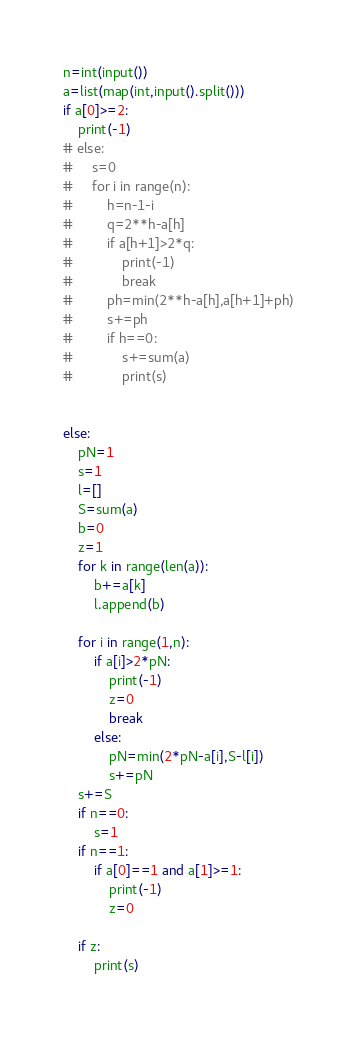Convert code to text. <code><loc_0><loc_0><loc_500><loc_500><_Python_>n=int(input())
a=list(map(int,input().split()))
if a[0]>=2:
    print(-1)
# else:
#     s=0
#     for i in range(n):
#         h=n-1-i
#         q=2**h-a[h]
#         if a[h+1]>2*q:
#             print(-1)
#             break
#         ph=min(2**h-a[h],a[h+1]+ph)
#         s+=ph
#         if h==0:
#             s+=sum(a)
#             print(s)


else:
    pN=1
    s=1
    l=[]
    S=sum(a)
    b=0
    z=1
    for k in range(len(a)):
        b+=a[k]
        l.append(b)

    for i in range(1,n):
        if a[i]>2*pN:
            print(-1)
            z=0
            break
        else:
            pN=min(2*pN-a[i],S-l[i])
            s+=pN
    s+=S
    if n==0:
        s=1
    if n==1:
        if a[0]==1 and a[1]>=1:
            print(-1)
            z=0

    if z:
        print(s)</code> 